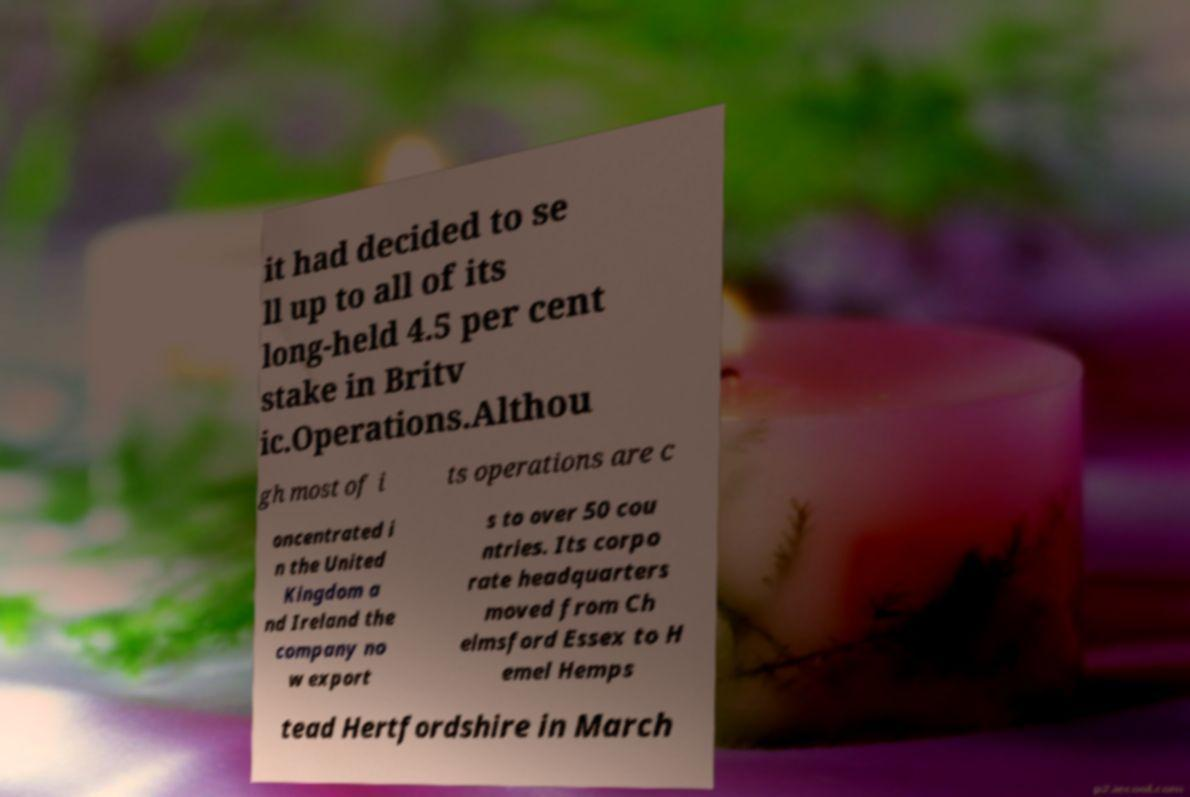Please read and relay the text visible in this image. What does it say? it had decided to se ll up to all of its long-held 4.5 per cent stake in Britv ic.Operations.Althou gh most of i ts operations are c oncentrated i n the United Kingdom a nd Ireland the company no w export s to over 50 cou ntries. Its corpo rate headquarters moved from Ch elmsford Essex to H emel Hemps tead Hertfordshire in March 